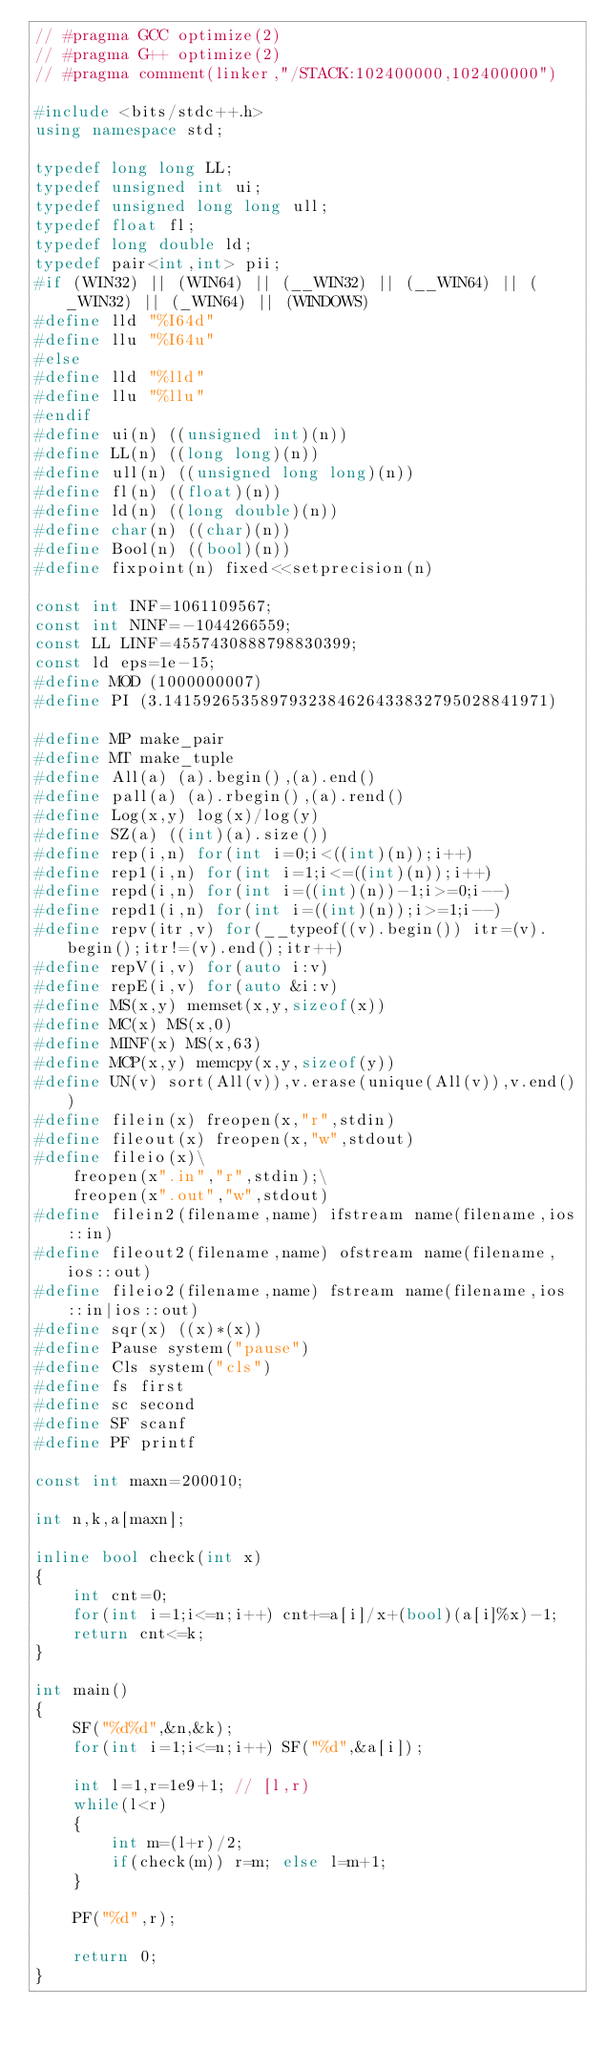<code> <loc_0><loc_0><loc_500><loc_500><_C++_>// #pragma GCC optimize(2)
// #pragma G++ optimize(2)
// #pragma comment(linker,"/STACK:102400000,102400000")

#include <bits/stdc++.h>
using namespace std;

typedef long long LL;
typedef unsigned int ui;
typedef unsigned long long ull;
typedef float fl;
typedef long double ld;
typedef pair<int,int> pii;
#if (WIN32) || (WIN64) || (__WIN32) || (__WIN64) || (_WIN32) || (_WIN64) || (WINDOWS)
#define lld "%I64d"
#define llu "%I64u"
#else
#define lld "%lld"
#define llu "%llu"
#endif
#define ui(n) ((unsigned int)(n))
#define LL(n) ((long long)(n))
#define ull(n) ((unsigned long long)(n))
#define fl(n) ((float)(n))
#define ld(n) ((long double)(n))
#define char(n) ((char)(n))
#define Bool(n) ((bool)(n))
#define fixpoint(n) fixed<<setprecision(n)

const int INF=1061109567;
const int NINF=-1044266559;
const LL LINF=4557430888798830399;
const ld eps=1e-15;
#define MOD (1000000007)
#define PI (3.1415926535897932384626433832795028841971)

#define MP make_pair
#define MT make_tuple
#define All(a) (a).begin(),(a).end()
#define pall(a) (a).rbegin(),(a).rend()
#define Log(x,y) log(x)/log(y)
#define SZ(a) ((int)(a).size())
#define rep(i,n) for(int i=0;i<((int)(n));i++)
#define rep1(i,n) for(int i=1;i<=((int)(n));i++)
#define repd(i,n) for(int i=((int)(n))-1;i>=0;i--)
#define repd1(i,n) for(int i=((int)(n));i>=1;i--)
#define repv(itr,v) for(__typeof((v).begin()) itr=(v).begin();itr!=(v).end();itr++)
#define repV(i,v) for(auto i:v)
#define repE(i,v) for(auto &i:v)
#define MS(x,y) memset(x,y,sizeof(x))
#define MC(x) MS(x,0)
#define MINF(x) MS(x,63)
#define MCP(x,y) memcpy(x,y,sizeof(y))
#define UN(v) sort(All(v)),v.erase(unique(All(v)),v.end())
#define filein(x) freopen(x,"r",stdin)
#define fileout(x) freopen(x,"w",stdout)
#define fileio(x)\
	freopen(x".in","r",stdin);\
	freopen(x".out","w",stdout)
#define filein2(filename,name) ifstream name(filename,ios::in)
#define fileout2(filename,name) ofstream name(filename,ios::out)
#define fileio2(filename,name) fstream name(filename,ios::in|ios::out)
#define sqr(x) ((x)*(x))
#define Pause system("pause")
#define Cls system("cls")
#define fs first
#define sc second
#define SF scanf
#define PF printf

const int maxn=200010;

int n,k,a[maxn];

inline bool check(int x)
{
	int cnt=0;
	for(int i=1;i<=n;i++) cnt+=a[i]/x+(bool)(a[i]%x)-1;
	return cnt<=k;
}

int main()
{
	SF("%d%d",&n,&k);
	for(int i=1;i<=n;i++) SF("%d",&a[i]);

	int l=1,r=1e9+1; // [l,r)
	while(l<r)
	{
		int m=(l+r)/2;
		if(check(m)) r=m; else l=m+1;
	}

	PF("%d",r);

	return 0;
}</code> 